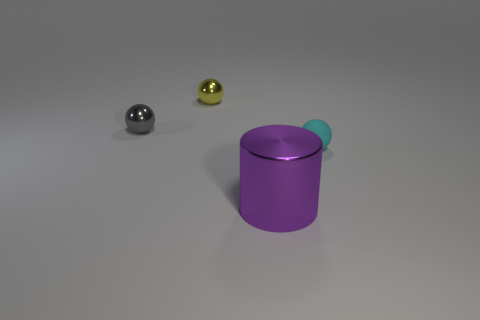Add 4 spheres. How many objects exist? 8 Subtract all cylinders. How many objects are left? 3 Add 1 large purple cylinders. How many large purple cylinders are left? 2 Add 2 metal cylinders. How many metal cylinders exist? 3 Subtract 0 cyan cylinders. How many objects are left? 4 Subtract all purple shiny cylinders. Subtract all yellow metal spheres. How many objects are left? 2 